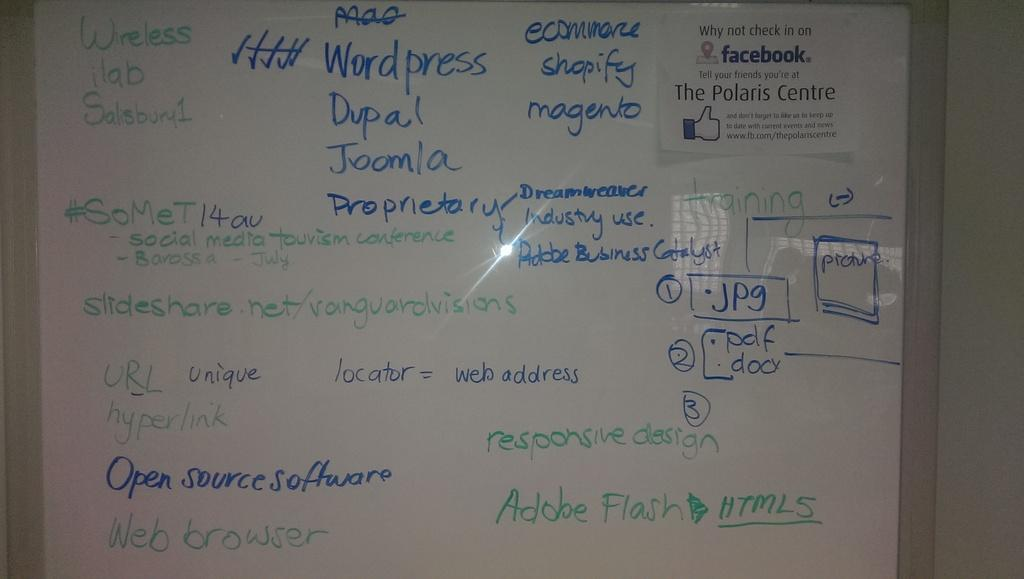<image>
Share a concise interpretation of the image provided. The teacher puts up programming notes on the whiteboard for his students. 